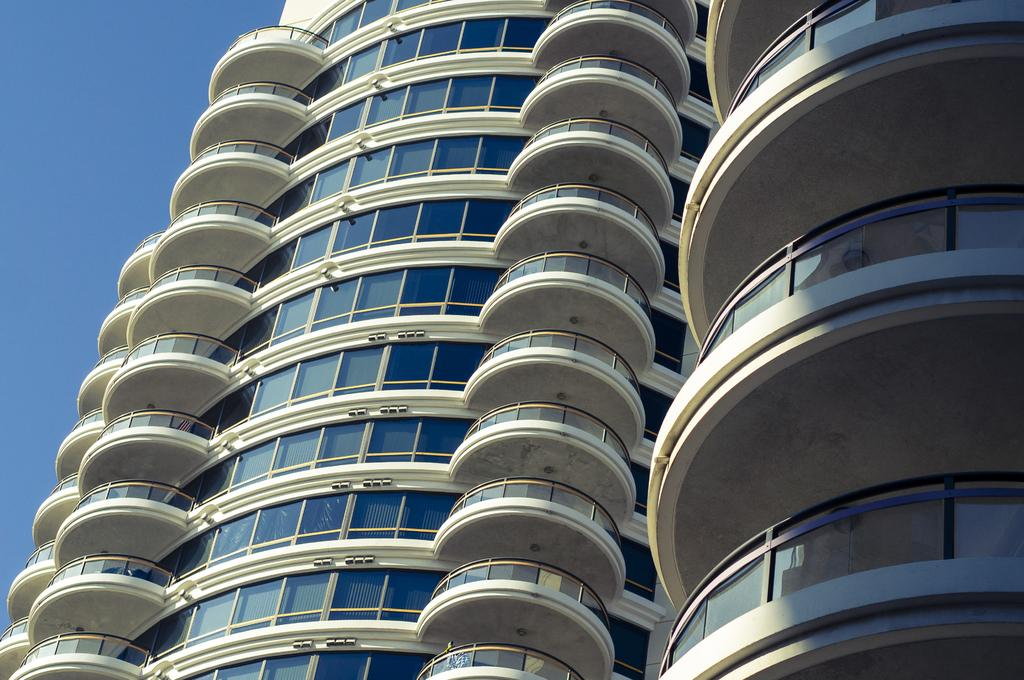What type of buildings are visible in the image? There are buildings with glass in the image. What else can be seen in the image besides the buildings? There are other objects in the image. What part of the sky is visible in the image? The sky is visible on the left side of the image. What type of pin is being used by the secretary in the image? There is no secretary or pin present in the image. 